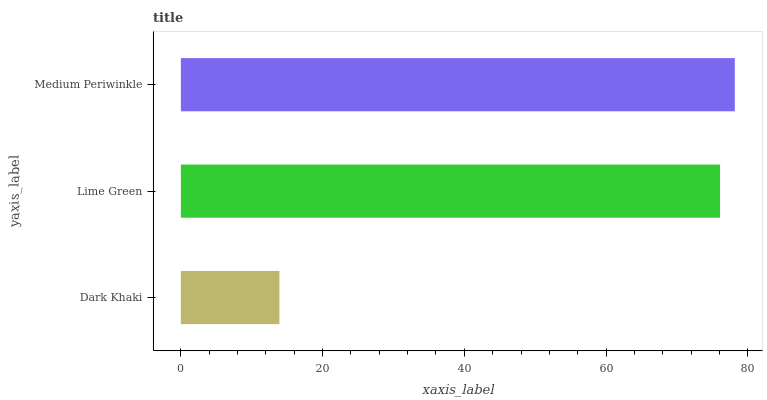Is Dark Khaki the minimum?
Answer yes or no. Yes. Is Medium Periwinkle the maximum?
Answer yes or no. Yes. Is Lime Green the minimum?
Answer yes or no. No. Is Lime Green the maximum?
Answer yes or no. No. Is Lime Green greater than Dark Khaki?
Answer yes or no. Yes. Is Dark Khaki less than Lime Green?
Answer yes or no. Yes. Is Dark Khaki greater than Lime Green?
Answer yes or no. No. Is Lime Green less than Dark Khaki?
Answer yes or no. No. Is Lime Green the high median?
Answer yes or no. Yes. Is Lime Green the low median?
Answer yes or no. Yes. Is Medium Periwinkle the high median?
Answer yes or no. No. Is Medium Periwinkle the low median?
Answer yes or no. No. 